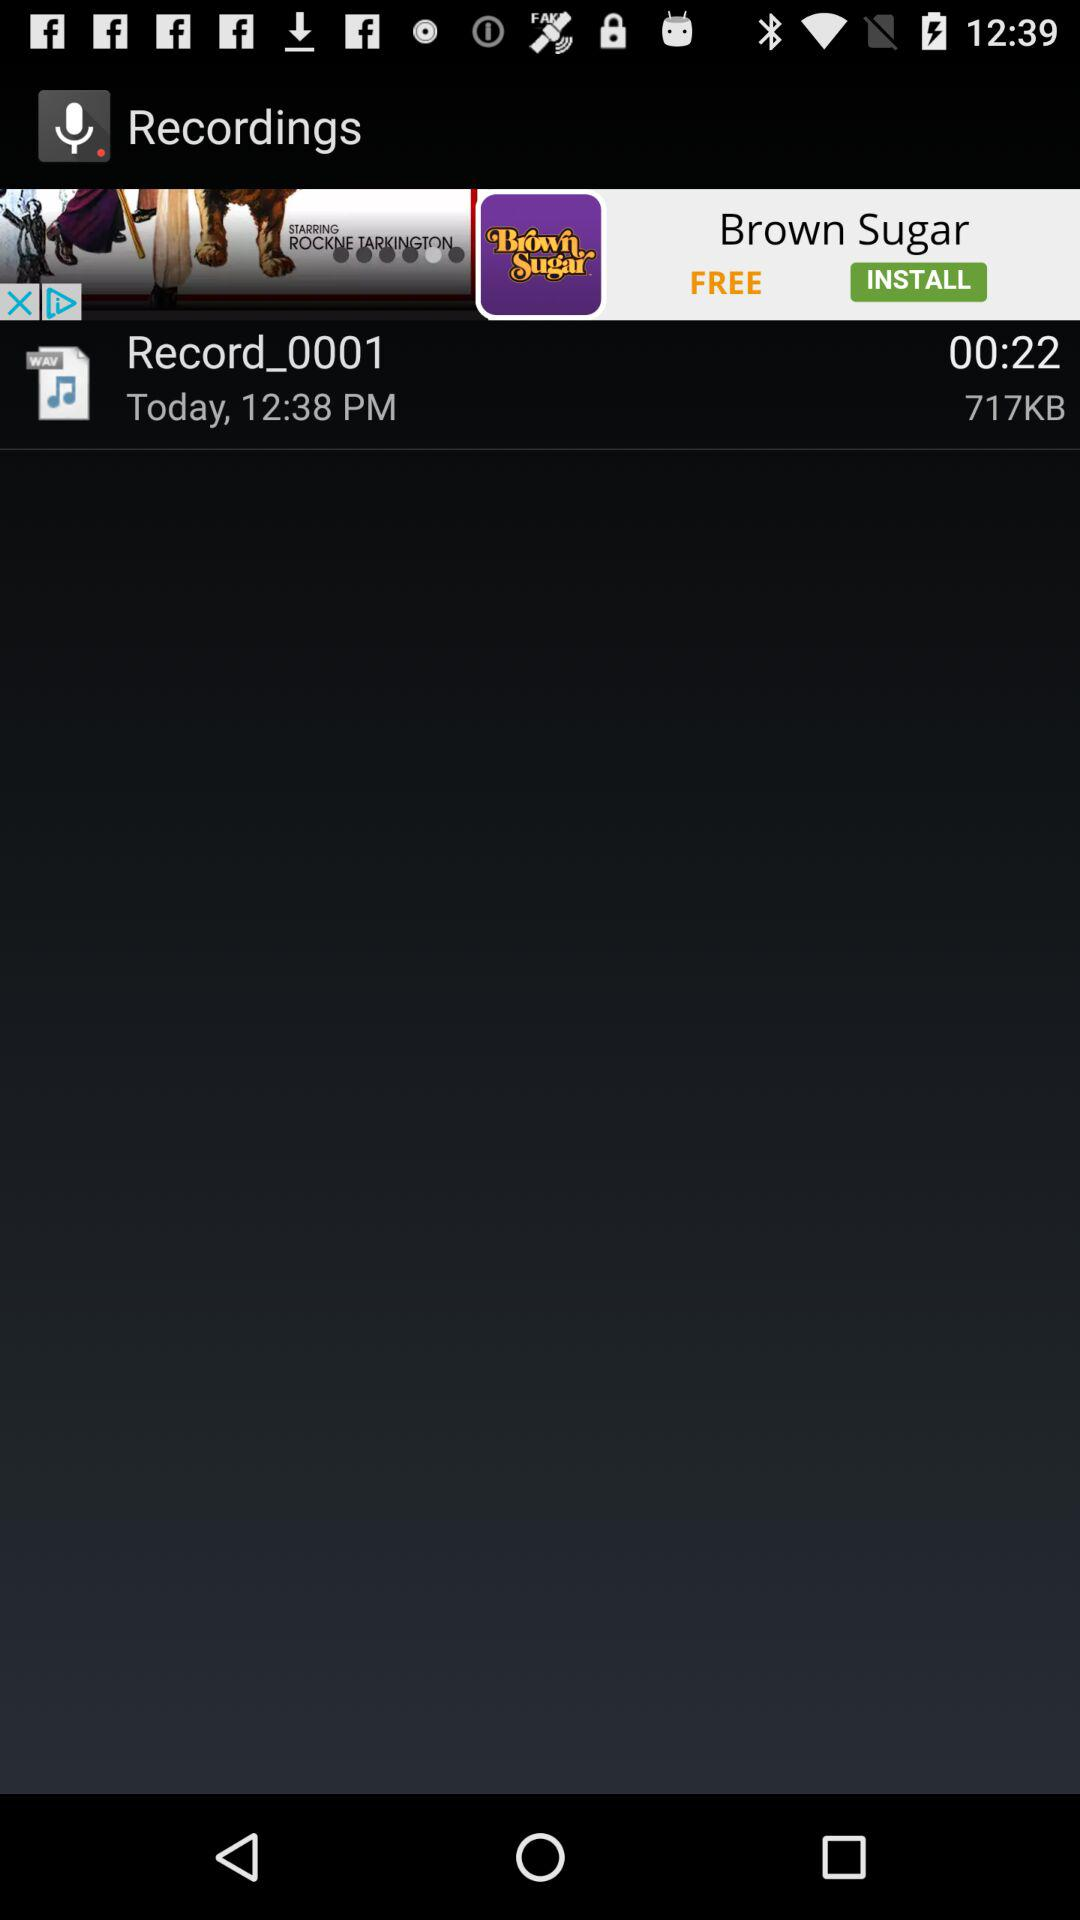How many bytes is the recording?
Answer the question using a single word or phrase. 717KB 